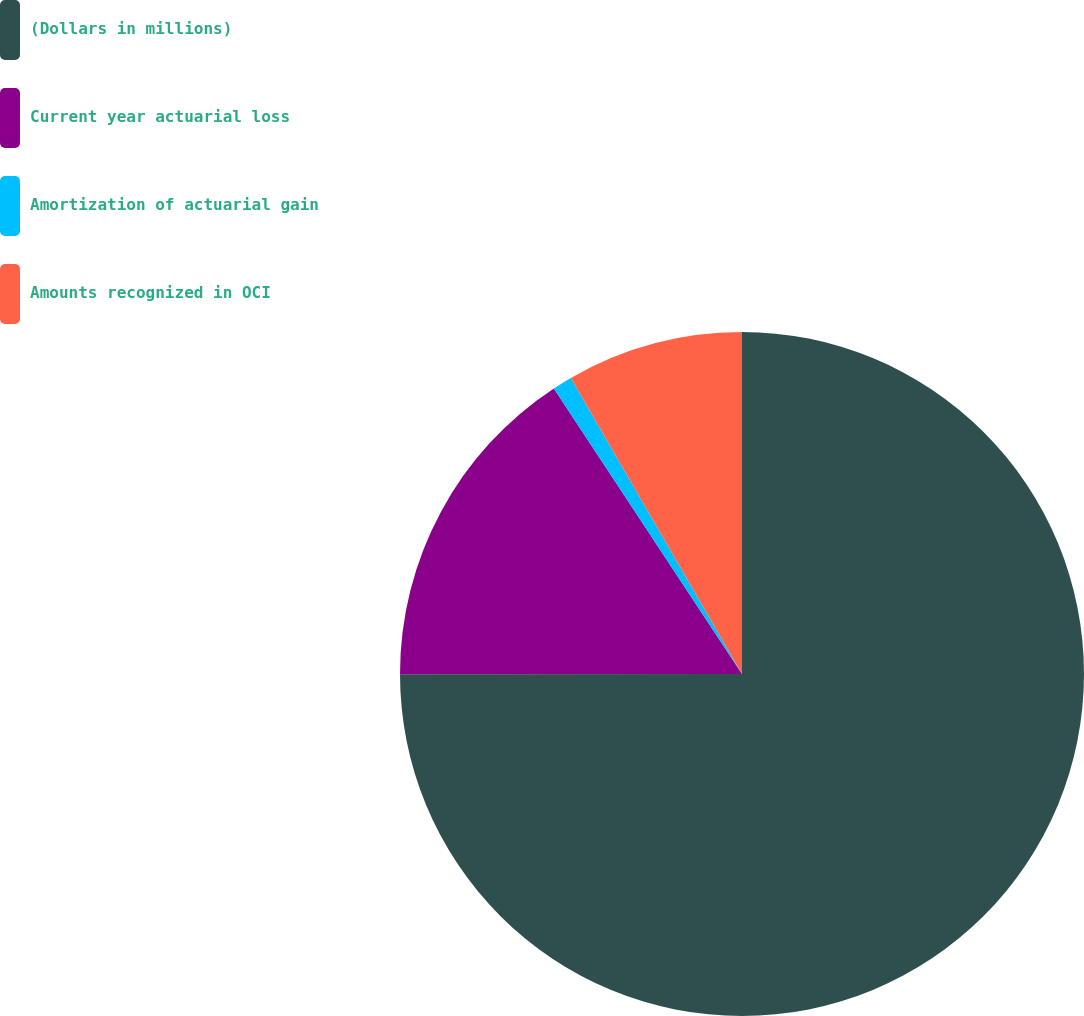Convert chart to OTSL. <chart><loc_0><loc_0><loc_500><loc_500><pie_chart><fcel>(Dollars in millions)<fcel>Current year actuarial loss<fcel>Amortization of actuarial gain<fcel>Amounts recognized in OCI<nl><fcel>74.99%<fcel>15.74%<fcel>0.93%<fcel>8.34%<nl></chart> 